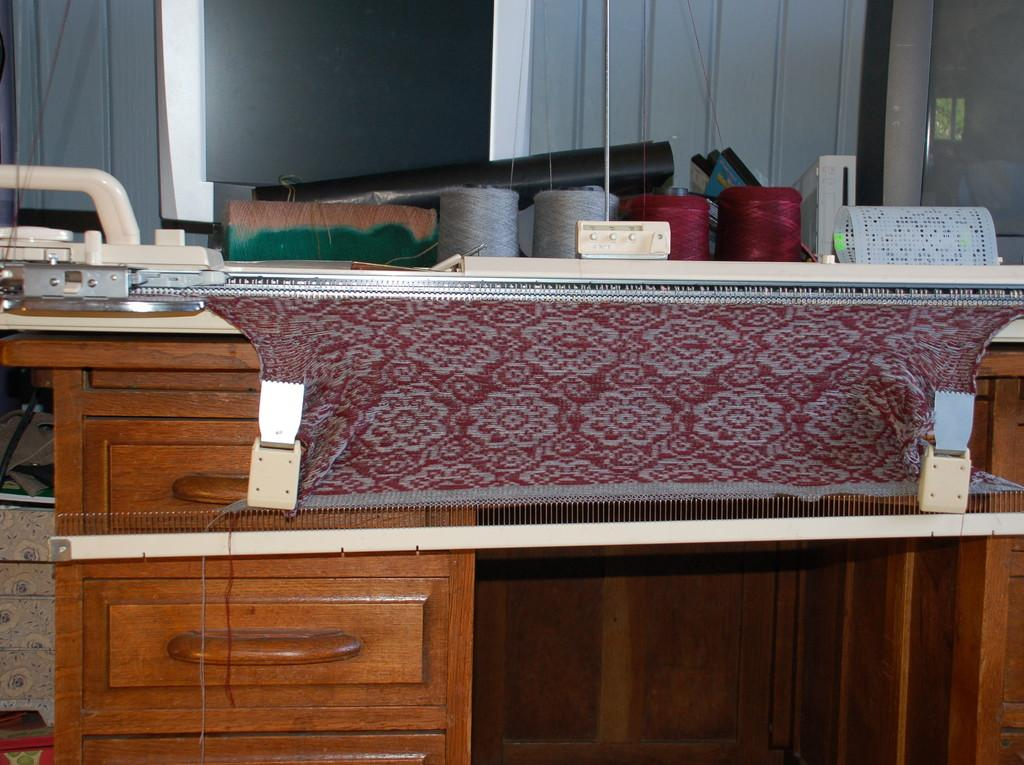What is present on the table in the image? There is a table in the image, and on it, there is a machine and a cloth. Can you describe the machine on the table? Unfortunately, the facts provided do not give any details about the machine on the table. What is the purpose of the cloth on the table? The purpose of the cloth on the table is not specified in the facts provided. What can be seen in the background of the image? In the background of the image, there are threads visible. What type of sack is hanging from the ceiling in the image? There is no sack hanging from the ceiling in the image. Can you describe the curtain on the window in the image? There is no window or curtain present in the image. 